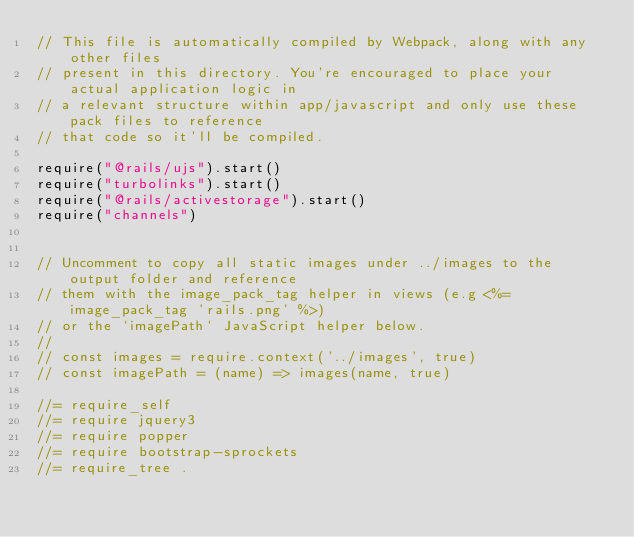<code> <loc_0><loc_0><loc_500><loc_500><_JavaScript_>// This file is automatically compiled by Webpack, along with any other files
// present in this directory. You're encouraged to place your actual application logic in
// a relevant structure within app/javascript and only use these pack files to reference
// that code so it'll be compiled.

require("@rails/ujs").start()
require("turbolinks").start()
require("@rails/activestorage").start()
require("channels")


// Uncomment to copy all static images under ../images to the output folder and reference
// them with the image_pack_tag helper in views (e.g <%= image_pack_tag 'rails.png' %>)
// or the `imagePath` JavaScript helper below.
//
// const images = require.context('../images', true)
// const imagePath = (name) => images(name, true)

//= require_self
//= require jquery3
//= require popper
//= require bootstrap-sprockets
//= require_tree .</code> 